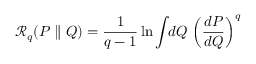Convert formula to latex. <formula><loc_0><loc_0><loc_500><loc_500>\mathcal { R } _ { q } ( P \| Q ) = \frac { 1 } { q - 1 } \ln \int \, d Q \, \left ( \frac { d P } { d Q } \right ) ^ { q }</formula> 